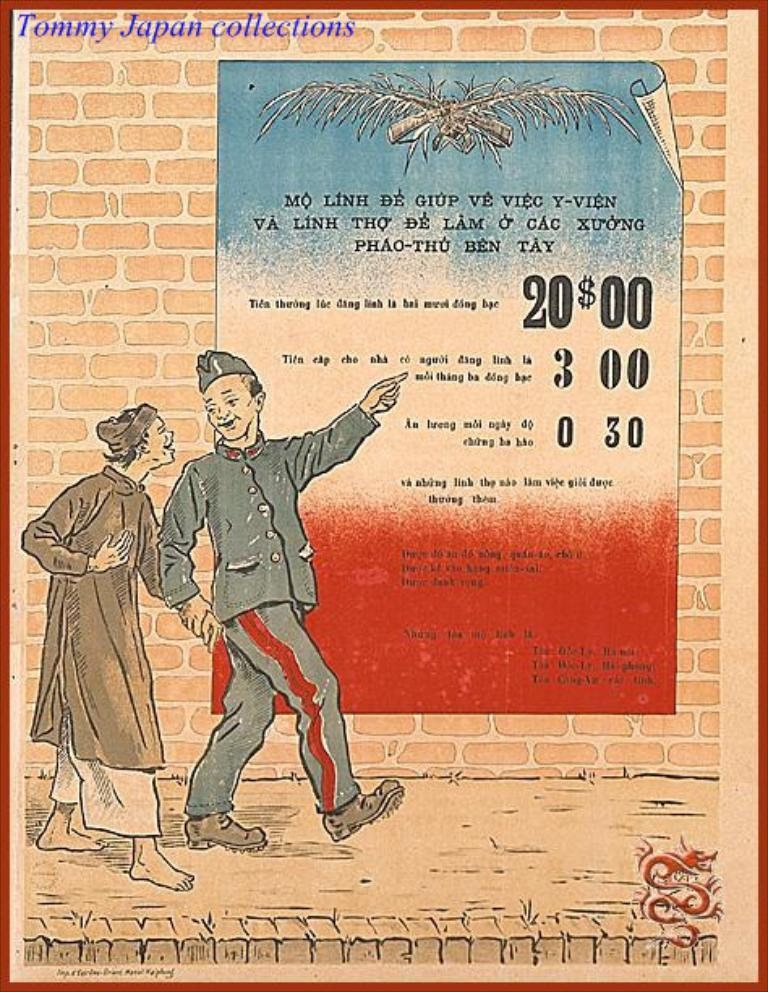How many people are in the image? There are two persons standing in the image. Where are the persons standing? The persons are standing on a sidewalk. What can be seen attached to a wall in the image? There is a paper stuck to a wall in the image. Can you describe any imperfections or marks in the image? Yes, there are watermarks present in the image. What type of meal are the persons sharing in the image? There is no meal present in the image; the persons are standing on a sidewalk and there is a paper stuck to a wall. How many children are visible in the image? There are no children visible in the image; it features two adults standing on a sidewalk. 